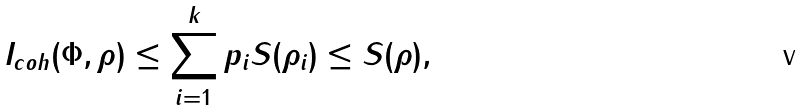Convert formula to latex. <formula><loc_0><loc_0><loc_500><loc_500>I _ { c o h } ( \Phi , \rho ) \leq \sum _ { i = 1 } ^ { k } p _ { i } S ( \rho _ { i } ) \leq S ( \rho ) ,</formula> 